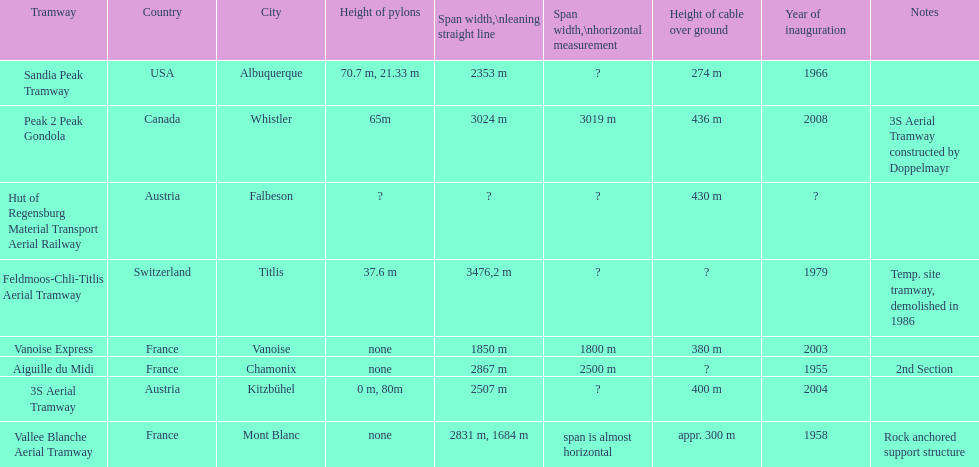How much longer is the peak 2 peak gondola than the 32 aerial tramway? 517. 